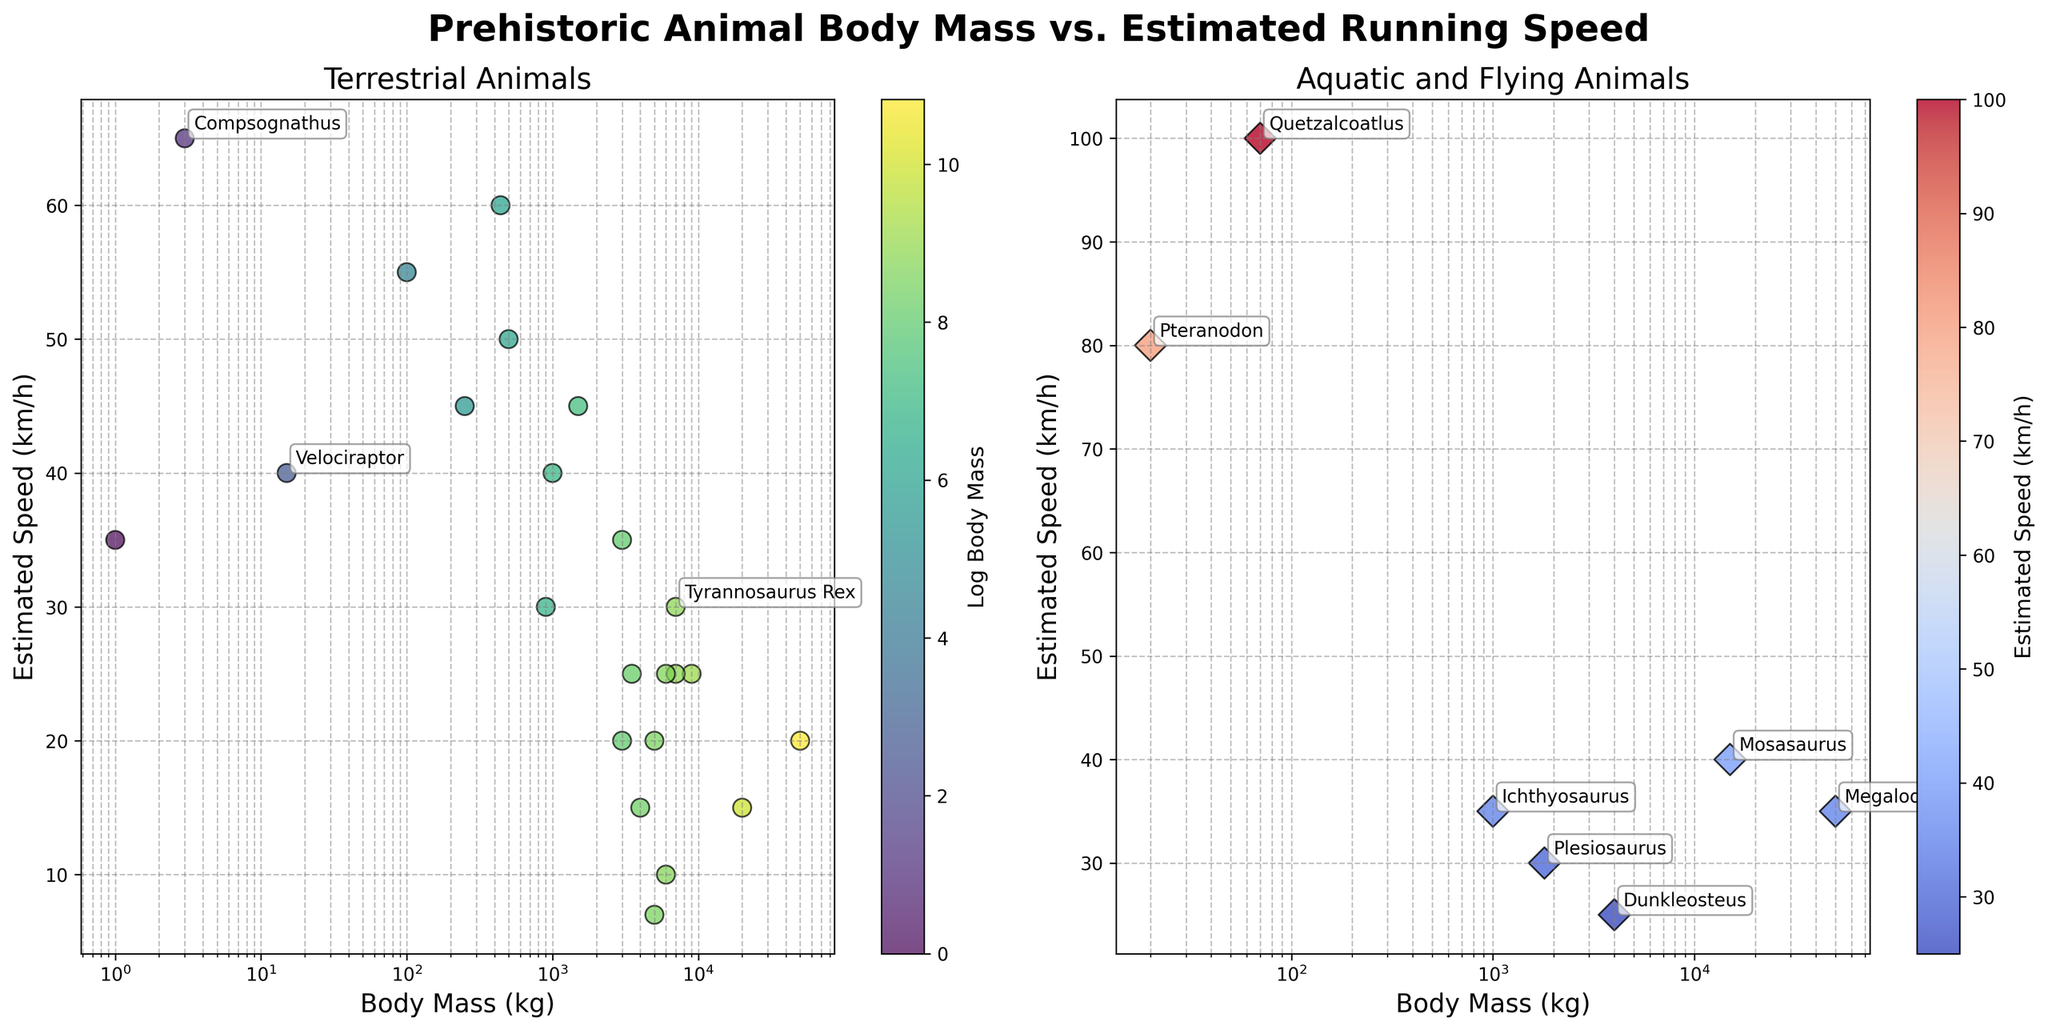How are terrestrial and aquatic/flying animals differentiated in the plot? Terrestrial animals are shown in the left subplot, while aquatic and flying animals appear in the right subplot, as indicated by the titles "Terrestrial Animals" and "Aquatic and Flying Animals" respectively.
Answer: By subplot category Which animal has the highest estimated speed among the terrestrial animals? By examining the maximum estimated speed on the terrestrial plot, "Compsognathus" has the highest estimated speed.
Answer: Compsognathus What is the relationship between body mass and estimated speed for terrestrial animals? For terrestrial animals, there isn't a clear linear relationship; heavier animals generally have slower speeds, but there are exceptions like Velociraptor with a relatively small body mass and high speed.
Answer: Inconclusive with exceptions How do the body masses of "Megalodon" and "Brachiosaurus" compare? Both "Megalodon" and "Brachiosaurus" have similar high body masses, around 50,000 kg each.
Answer: Similar body masses Which animal has the highest estimated speed overall? From the right subplot, "Quetzalcoatlus" as an aquatic/flying animal has the highest estimated speed at 100 km/h.
Answer: Quetzalcoatlus Which group (terrestrial or aquatic/flying) shows a higher range of speeds? By looking at the spread in the plot, aquatic/flying animals (right subplot) show a wider range in speeds ranging from 25 km/h to 100 km/h, compared to terrestrial animals.
Answer: Aquatic/flying animals How does the log body mass correlate with speed for terrestrial animals? The color gradient (viridis colormap) in the left plot suggests animals with larger body masses generally have lower estimated speeds, but there are exceptions.
Answer: Negative correlation with exceptions Is there an example where two animals with similar body masses have different estimated speeds? "Tyrannosaurus Rex" and "Spinosaurus" both have a body mass of about 7,000 kg, but "Tyrannosaurus Rex" has a speed of 30 km/h while "Spinosaurus" has a speed of 25 km/h.
Answer: Tyrannosaurus Rex and Spinosaurus Considering the annotated terrestrial animals, which one is the fastest? Among the annotated animals, "Compsognathus" is the fastest with an estimated speed of 65 km/h.
Answer: Compsognathus 